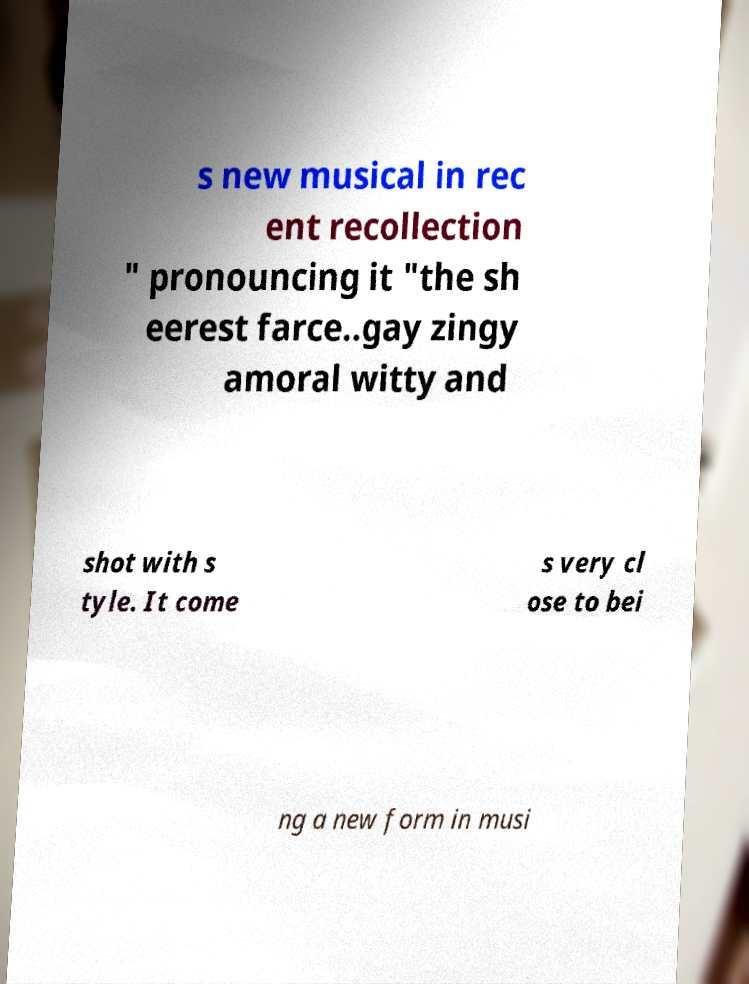Could you extract and type out the text from this image? s new musical in rec ent recollection " pronouncing it "the sh eerest farce..gay zingy amoral witty and shot with s tyle. It come s very cl ose to bei ng a new form in musi 